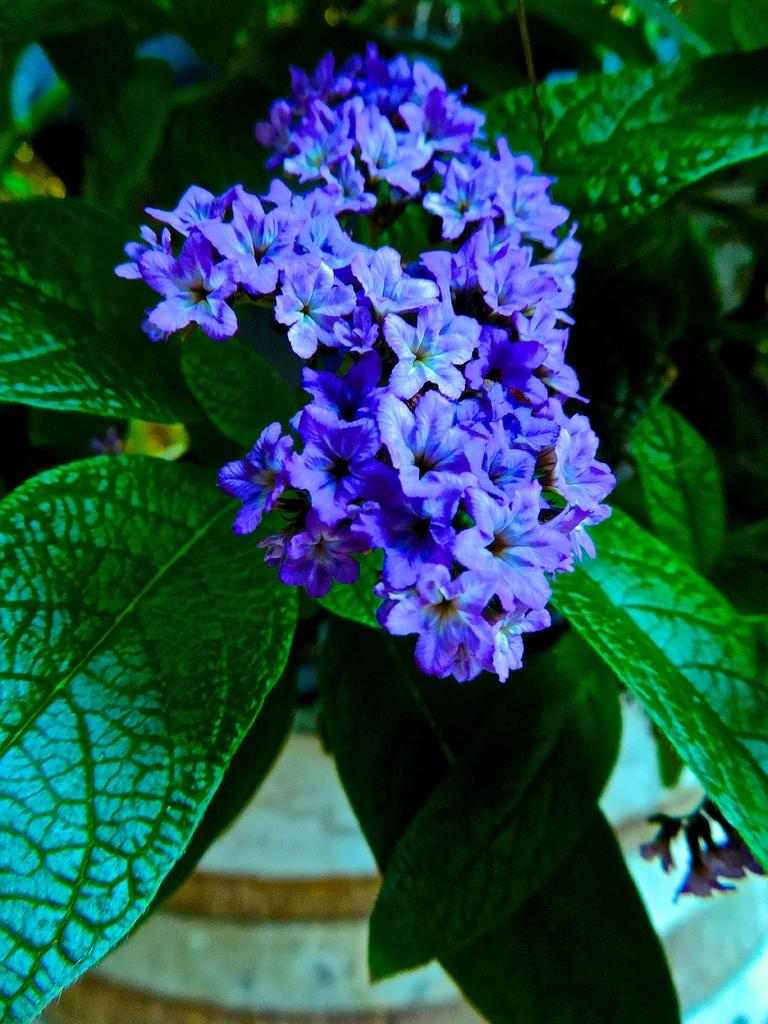What type of plant is in the image? There is a plant in the image. What features can be observed on the plant? The plant has flowers and leaves. What is visible in the background of the image? There is a floor visible in the background of the image. What type of star can be seen in the image? There is no star present in the image; it features a plant with flowers and leaves. What fact can be learned about the plant from the image? The image shows that the plant has flowers and leaves, but it does not provide any additional facts about the plant. 